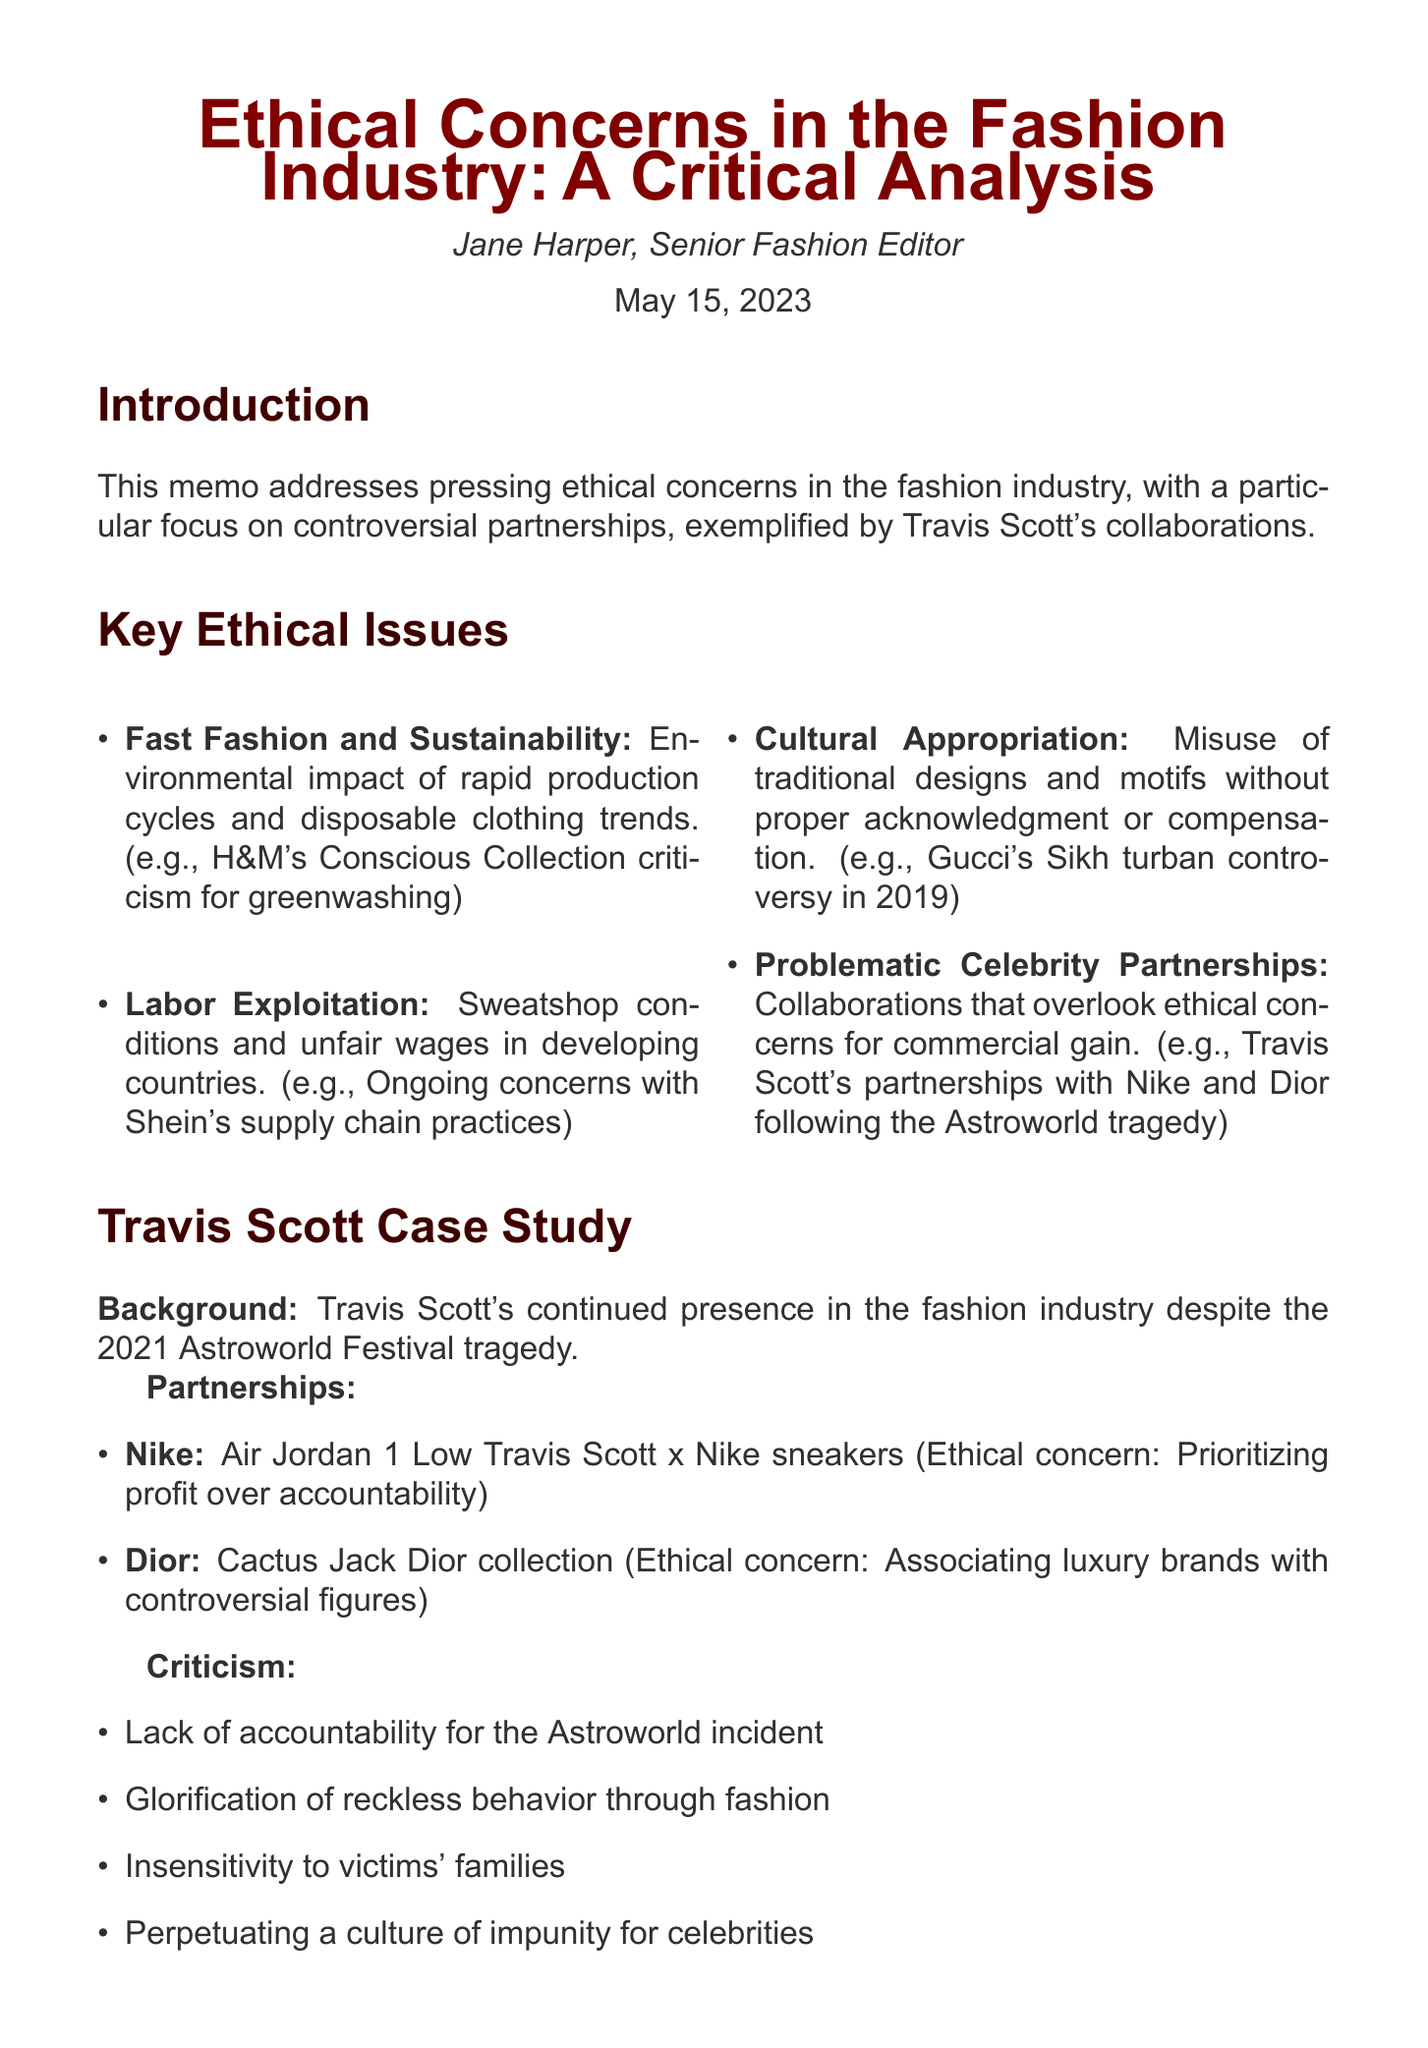What is the title of the memo? The title of the memo is presented in the header of the document.
Answer: Ethical Concerns in the Fashion Industry: A Critical Analysis Who is the author of the memo? The author of the memo is listed under the title.
Answer: Jane Harper What date was the memo written? The date is provided at the end of the author section.
Answer: May 15, 2023 What is one example of fast fashion criticism mentioned? The document lists specific examples under each ethical issue.
Answer: H&M's Conscious Collection criticism for greenwashing What was one of Travis Scott's partnerships mentioned? The memo lists partnerships of Travis Scott with specific brands.
Answer: Nike What is one ethical concern regarding Travis Scott's partnership with Dior? Ethical concerns are detailed for each partnership within the case study.
Answer: Associating luxury brands with controversial figures What industry recommendation suggests changes to celebrity partnerships? Recommendations are structured in a way that suggests improvements to current practices.
Answer: Implement stricter vetting processes for celebrity partnerships What main criticism is directed towards the fashion industry's response to the Astroworld incident? The memo summarizes criticisms in the section dedicated to Travis Scott's partnerships.
Answer: Lack of accountability for the Astroworld incident 